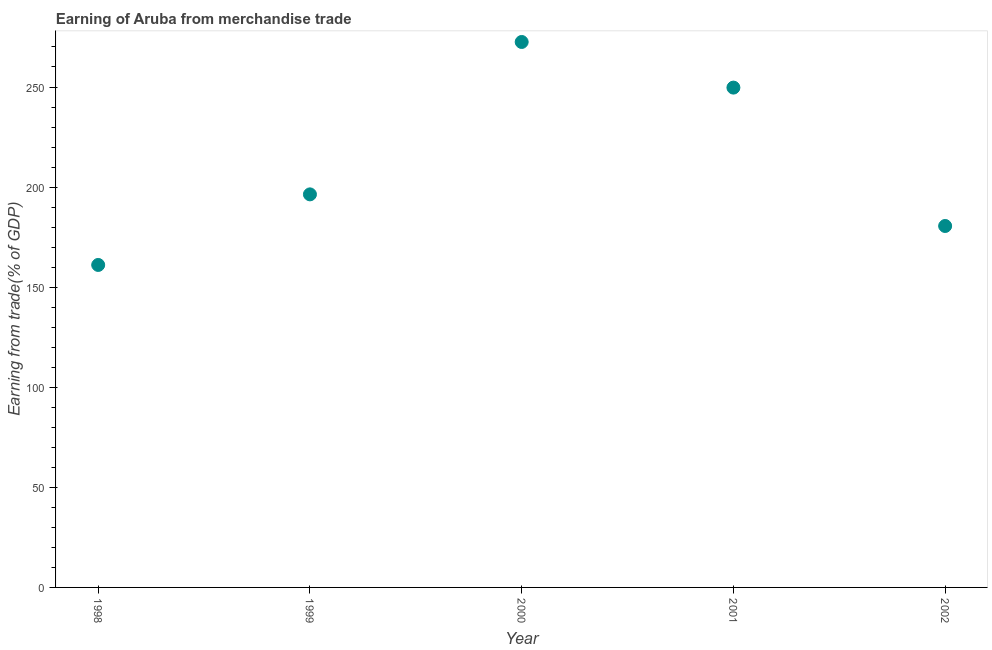What is the earning from merchandise trade in 1999?
Give a very brief answer. 196.36. Across all years, what is the maximum earning from merchandise trade?
Give a very brief answer. 272.5. Across all years, what is the minimum earning from merchandise trade?
Your answer should be very brief. 161.1. In which year was the earning from merchandise trade maximum?
Your response must be concise. 2000. What is the sum of the earning from merchandise trade?
Your answer should be compact. 1060.23. What is the difference between the earning from merchandise trade in 2001 and 2002?
Keep it short and to the point. 69.13. What is the average earning from merchandise trade per year?
Ensure brevity in your answer.  212.05. What is the median earning from merchandise trade?
Your answer should be very brief. 196.36. Do a majority of the years between 1998 and 1999 (inclusive) have earning from merchandise trade greater than 40 %?
Keep it short and to the point. Yes. What is the ratio of the earning from merchandise trade in 2000 to that in 2002?
Your answer should be very brief. 1.51. What is the difference between the highest and the second highest earning from merchandise trade?
Offer a very short reply. 22.8. What is the difference between the highest and the lowest earning from merchandise trade?
Offer a very short reply. 111.39. In how many years, is the earning from merchandise trade greater than the average earning from merchandise trade taken over all years?
Ensure brevity in your answer.  2. Does the earning from merchandise trade monotonically increase over the years?
Offer a very short reply. No. How many dotlines are there?
Your answer should be very brief. 1. What is the difference between two consecutive major ticks on the Y-axis?
Give a very brief answer. 50. Does the graph contain any zero values?
Keep it short and to the point. No. Does the graph contain grids?
Your answer should be compact. No. What is the title of the graph?
Make the answer very short. Earning of Aruba from merchandise trade. What is the label or title of the Y-axis?
Your response must be concise. Earning from trade(% of GDP). What is the Earning from trade(% of GDP) in 1998?
Offer a very short reply. 161.1. What is the Earning from trade(% of GDP) in 1999?
Give a very brief answer. 196.36. What is the Earning from trade(% of GDP) in 2000?
Offer a very short reply. 272.5. What is the Earning from trade(% of GDP) in 2001?
Your answer should be compact. 249.7. What is the Earning from trade(% of GDP) in 2002?
Ensure brevity in your answer.  180.57. What is the difference between the Earning from trade(% of GDP) in 1998 and 1999?
Offer a terse response. -35.26. What is the difference between the Earning from trade(% of GDP) in 1998 and 2000?
Give a very brief answer. -111.39. What is the difference between the Earning from trade(% of GDP) in 1998 and 2001?
Ensure brevity in your answer.  -88.59. What is the difference between the Earning from trade(% of GDP) in 1998 and 2002?
Give a very brief answer. -19.46. What is the difference between the Earning from trade(% of GDP) in 1999 and 2000?
Offer a terse response. -76.13. What is the difference between the Earning from trade(% of GDP) in 1999 and 2001?
Offer a terse response. -53.33. What is the difference between the Earning from trade(% of GDP) in 1999 and 2002?
Make the answer very short. 15.8. What is the difference between the Earning from trade(% of GDP) in 2000 and 2001?
Your answer should be compact. 22.8. What is the difference between the Earning from trade(% of GDP) in 2000 and 2002?
Offer a very short reply. 91.93. What is the difference between the Earning from trade(% of GDP) in 2001 and 2002?
Offer a very short reply. 69.13. What is the ratio of the Earning from trade(% of GDP) in 1998 to that in 1999?
Provide a succinct answer. 0.82. What is the ratio of the Earning from trade(% of GDP) in 1998 to that in 2000?
Keep it short and to the point. 0.59. What is the ratio of the Earning from trade(% of GDP) in 1998 to that in 2001?
Keep it short and to the point. 0.65. What is the ratio of the Earning from trade(% of GDP) in 1998 to that in 2002?
Keep it short and to the point. 0.89. What is the ratio of the Earning from trade(% of GDP) in 1999 to that in 2000?
Give a very brief answer. 0.72. What is the ratio of the Earning from trade(% of GDP) in 1999 to that in 2001?
Your answer should be compact. 0.79. What is the ratio of the Earning from trade(% of GDP) in 1999 to that in 2002?
Your response must be concise. 1.09. What is the ratio of the Earning from trade(% of GDP) in 2000 to that in 2001?
Offer a very short reply. 1.09. What is the ratio of the Earning from trade(% of GDP) in 2000 to that in 2002?
Give a very brief answer. 1.51. What is the ratio of the Earning from trade(% of GDP) in 2001 to that in 2002?
Offer a very short reply. 1.38. 